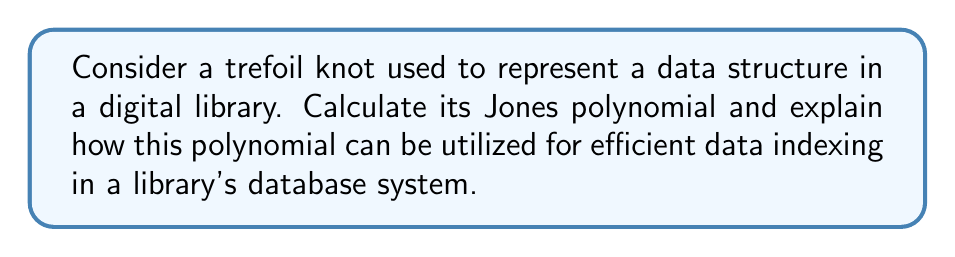Could you help me with this problem? Let's approach this step-by-step:

1) First, we need to calculate the Jones polynomial of a trefoil knot. The trefoil knot can be represented by the braid word $\sigma_1^3$.

2) The Jones polynomial for a trefoil knot is given by:

   $$V(t) = t + t^3 - t^4$$

3) To understand how this can be used for data indexing, let's break down the polynomial:
   
   a) The polynomial has three terms: $t$, $t^3$, and $-t^4$
   b) These terms can be used as a unique identifier for the trefoil knot

4) In a library database system, we can use this polynomial for indexing as follows:

   a) Assign each term of the polynomial to a specific category of data:
      - $t$ : Book category
      - $t^3$ : Author information
      - $-t^4$ : Publication details

   b) The coefficients (1, 1, -1) can be used to denote subcategories or specific attributes within each category

5) For efficient indexing:
   
   a) Create a hash function based on the Jones polynomial
   b) Use the hash to quickly locate and retrieve data
   c) The uniqueness of the Jones polynomial for different knots ensures minimal collisions in the hash table

6) This system allows for:
   
   a) Quick retrieval of data based on the knot structure
   b) Efficient organization of complex data structures
   c) Easy expansion to include more categories by using more complex knots with longer polynomials

7) For a librarian, this system provides:
   
   a) A mathematically robust way to organize digital information
   b) An efficient method for data retrieval in a transformed digital library system
   c) A unique approach to data warehousing that aligns with the fascination for digital transformation
Answer: $V(t) = t + t^3 - t^4$; Use terms as category identifiers and coefficients as subcategory markers in a hash-based indexing system. 